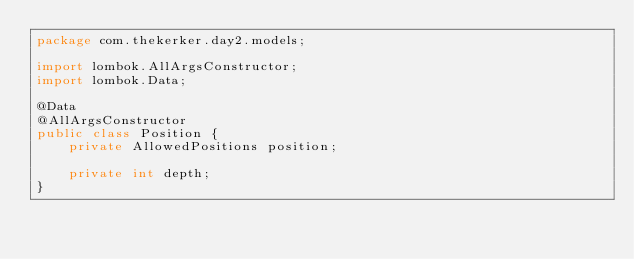<code> <loc_0><loc_0><loc_500><loc_500><_Java_>package com.thekerker.day2.models;

import lombok.AllArgsConstructor;
import lombok.Data;

@Data
@AllArgsConstructor
public class Position {
    private AllowedPositions position;

    private int depth;
}
</code> 